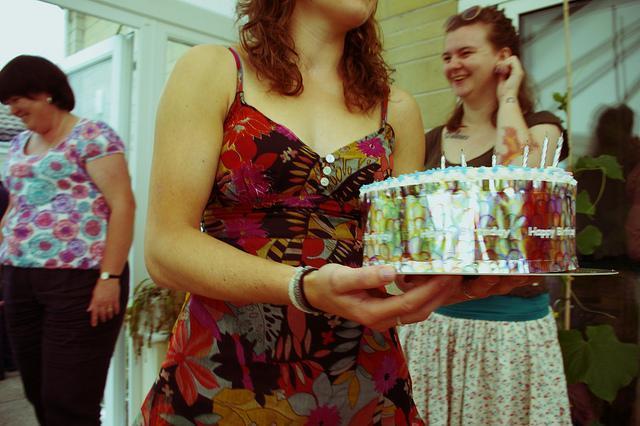How many people are in the shot?
Give a very brief answer. 3. How many people are in the picture?
Give a very brief answer. 3. 